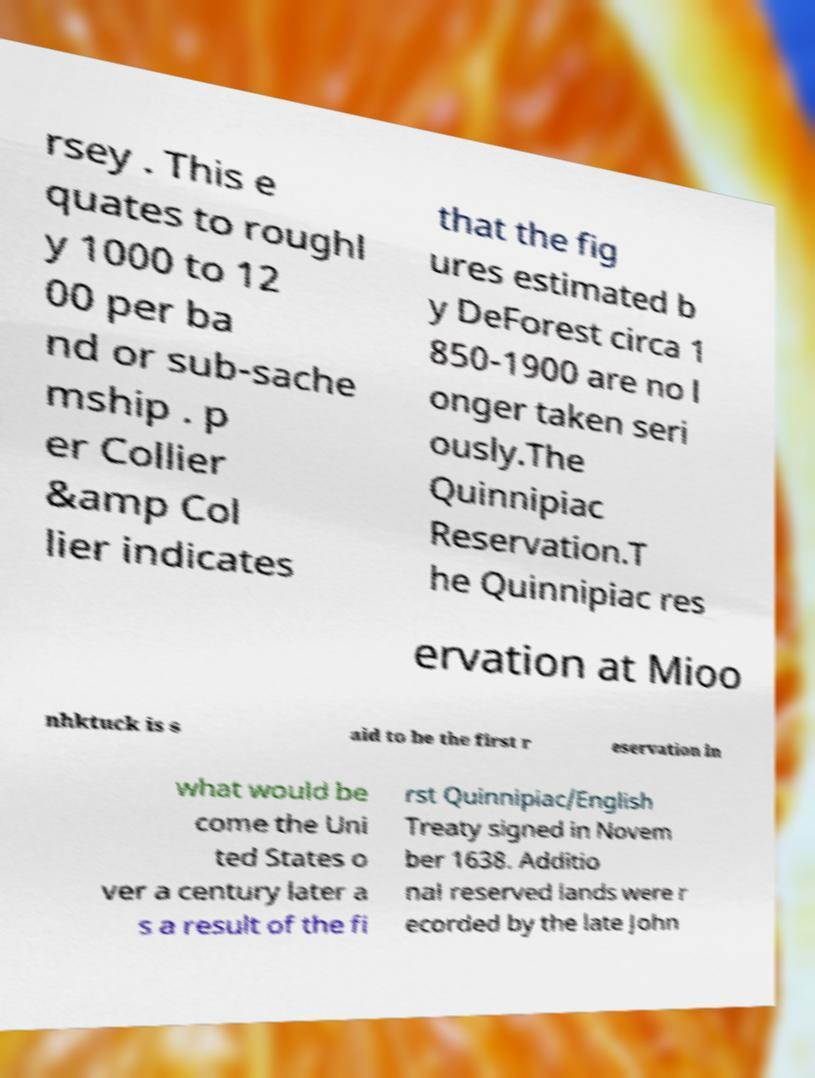I need the written content from this picture converted into text. Can you do that? rsey . This e quates to roughl y 1000 to 12 00 per ba nd or sub-sache mship . p er Collier &amp Col lier indicates that the fig ures estimated b y DeForest circa 1 850-1900 are no l onger taken seri ously.The Quinnipiac Reservation.T he Quinnipiac res ervation at Mioo nhktuck is s aid to be the first r eservation in what would be come the Uni ted States o ver a century later a s a result of the fi rst Quinnipiac/English Treaty signed in Novem ber 1638. Additio nal reserved lands were r ecorded by the late John 